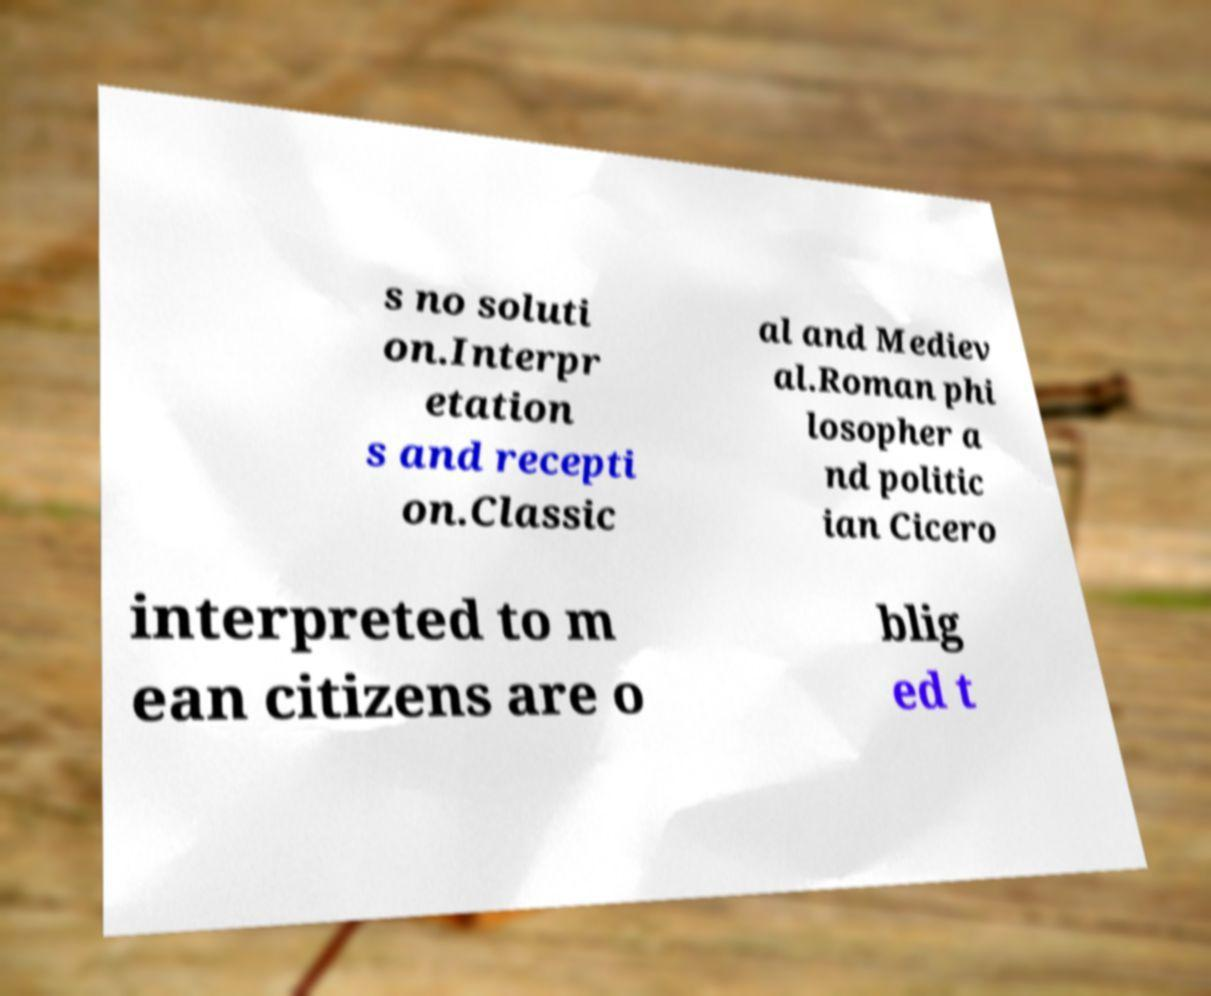Could you assist in decoding the text presented in this image and type it out clearly? s no soluti on.Interpr etation s and recepti on.Classic al and Mediev al.Roman phi losopher a nd politic ian Cicero interpreted to m ean citizens are o blig ed t 